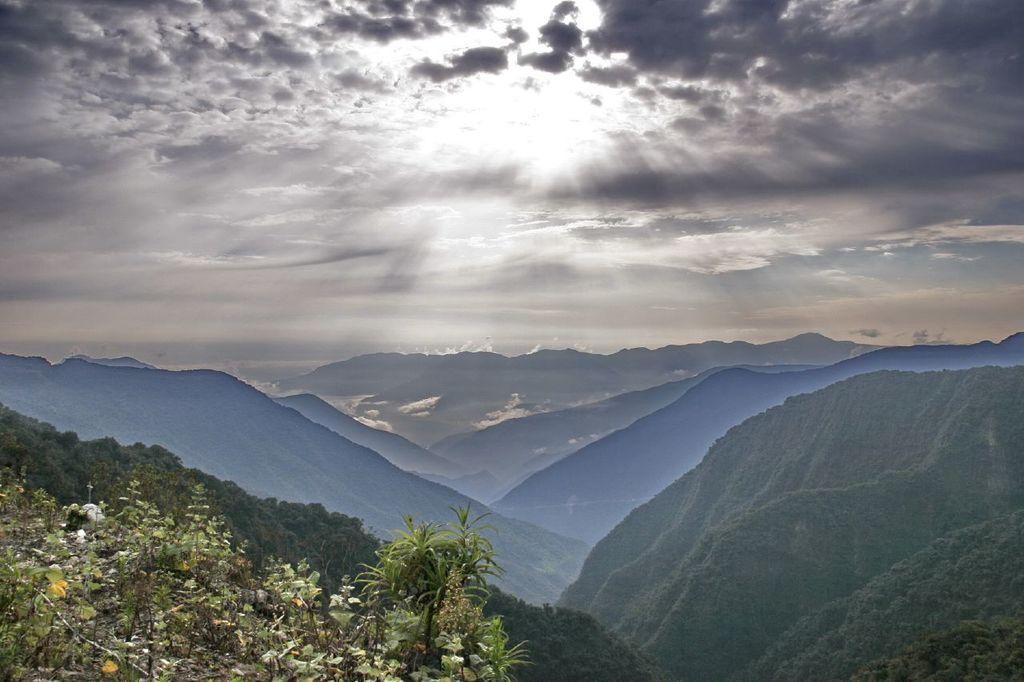Can you describe this image briefly? In this image, there is an outside view. In the foreground, there are some hills. In the background, there is a sky. 